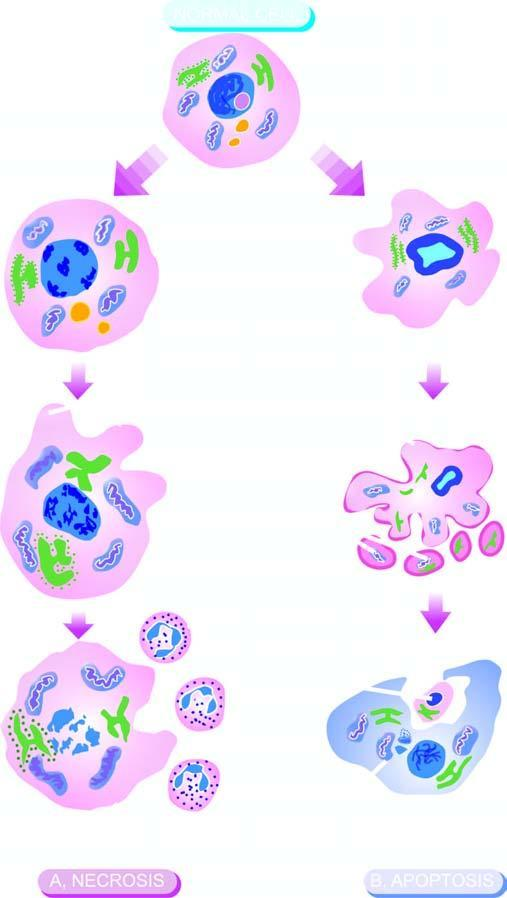s the cytoplasm identified by homogeneous, eosinophilic cytoplasm?
Answer the question using a single word or phrase. No 